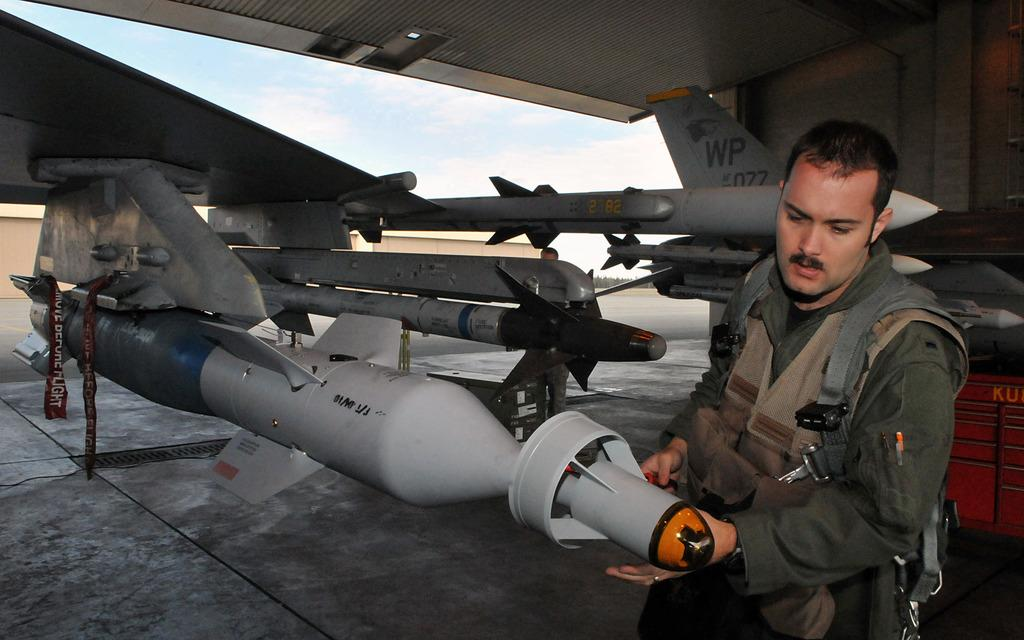Provide a one-sentence caption for the provided image. a military person in front of military weapons and a plane tail fin reading WP. 